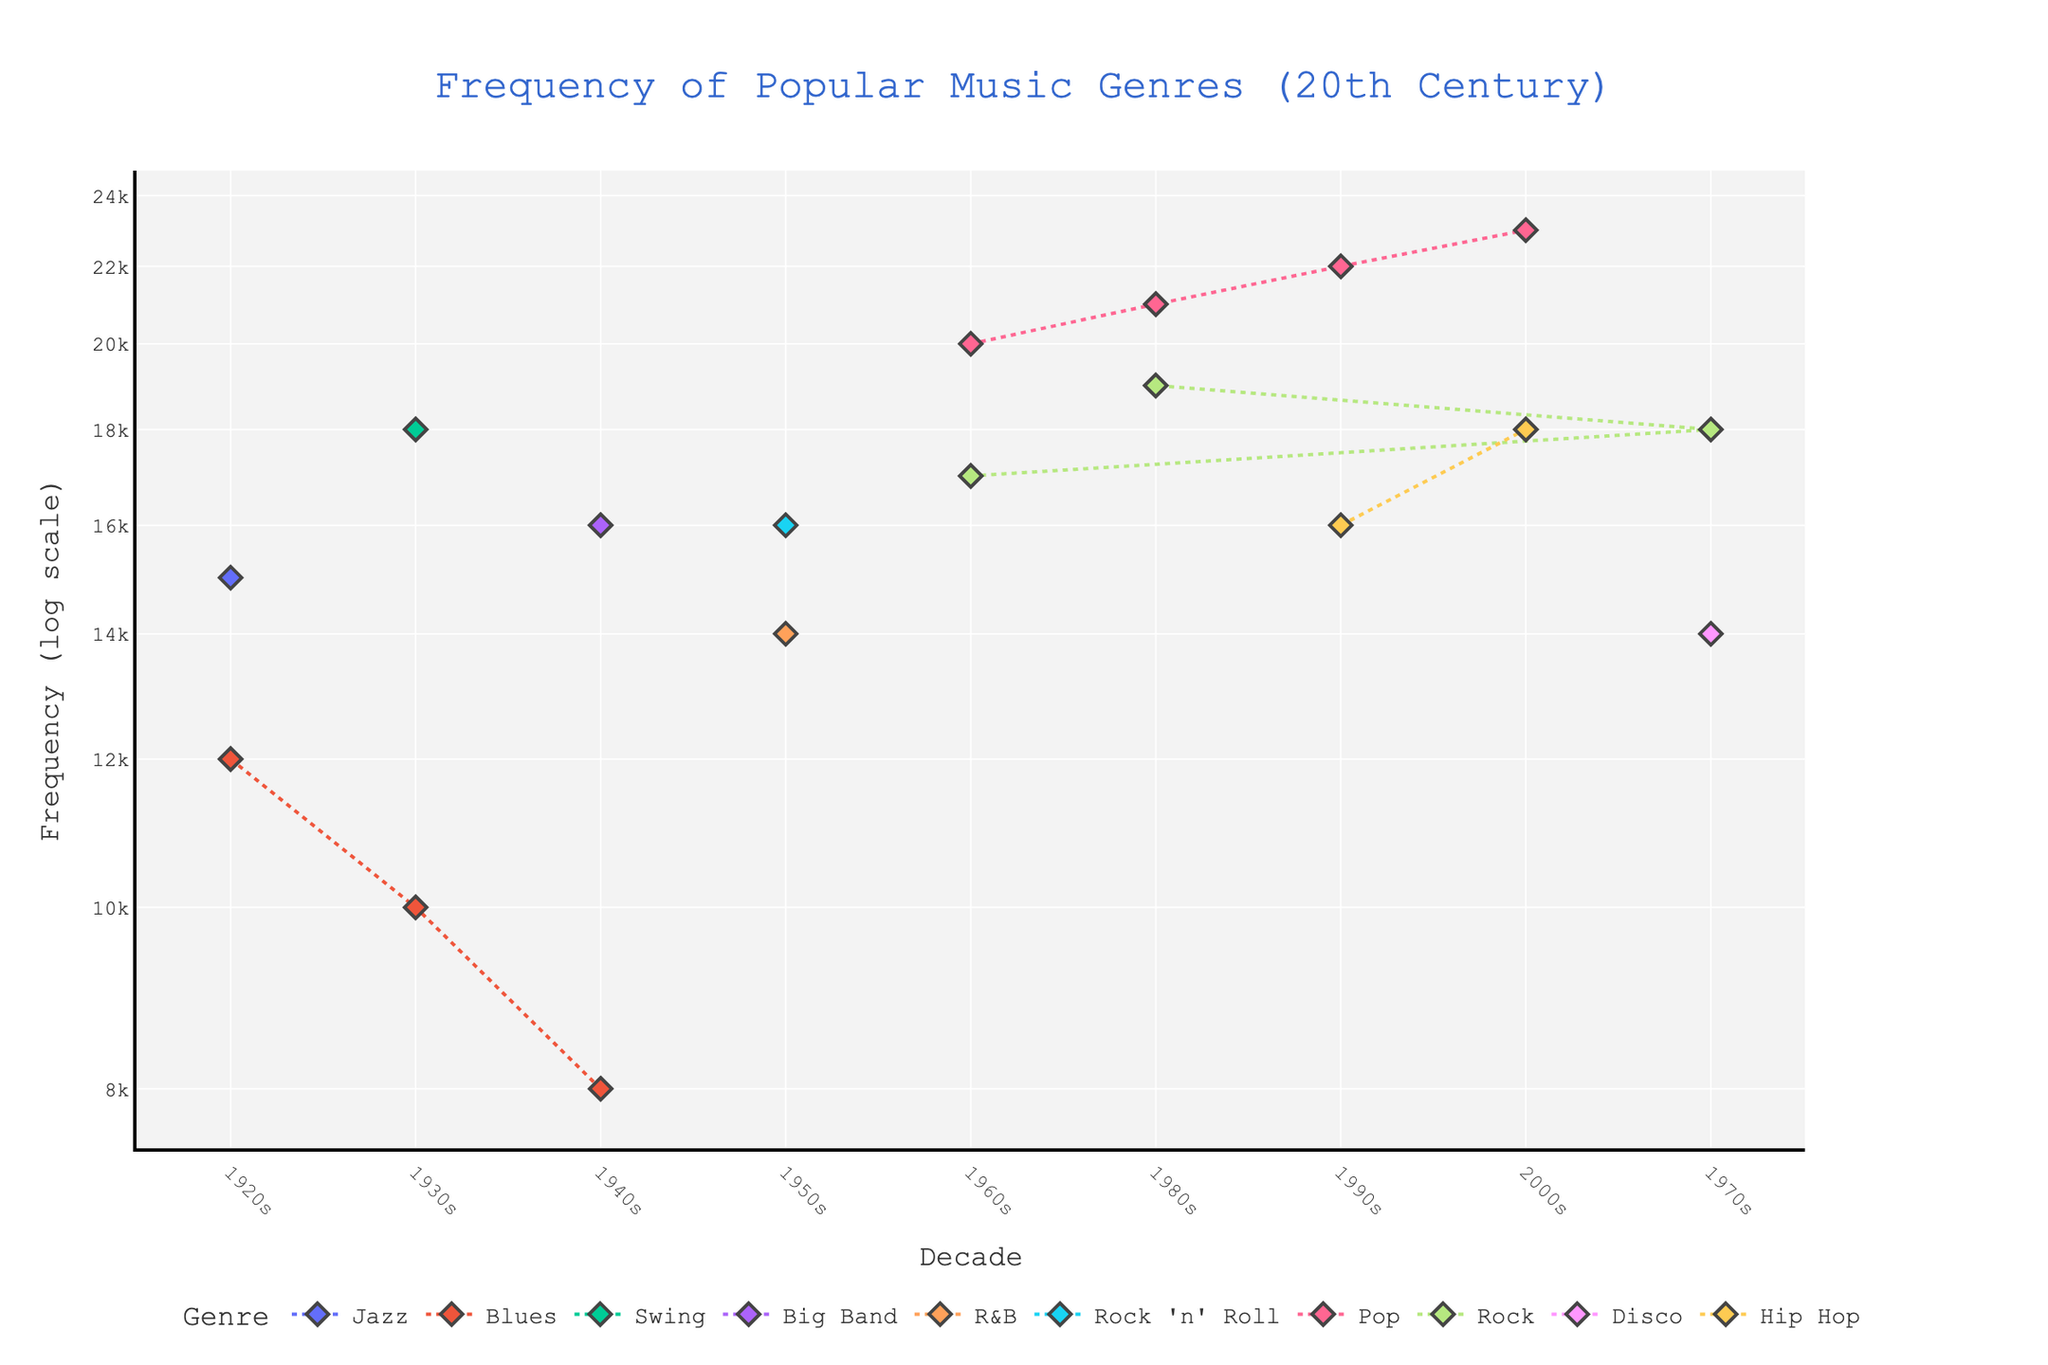What is the title of the plot? Look at the top of the plot where the title is located.
Answer: Frequency of Popular Music Genres (20th Century) How many genres are represented in the plot? Count the unique genres listed in the legend or within the plot data points.
Answer: 10 Which genre had the highest frequency in the 1980s? Identify the data points corresponding to the 1980s and compare their frequencies.
Answer: Pop Which decade had the highest frequency for Pop music? Look at the data points for Pop music across all decades and identify the highest frequency.
Answer: 2000s How does the frequency of Rock music in the 1960s compare to the 1970s? Find the frequencies of Rock music in the 1960s (17000) and 1970s (18000) and compare them.
Answer: 1970s has a higher frequency by 1000 Which genres were popular in both the 1920s and 1930s? Identify the genres listed in both the 1920s and 1930s and compare them.
Answer: Blues Does the frequency of Blues music increase or decrease from the 1920s to the 1940s? Compare the frequency values of Blues music across the 1920s (12000), 1930s (10000), and 1940s (8000).
Answer: Decrease Which genre shows a continuous increase in frequency from the 1950s to the 2000s? Examine the genres' frequencies across these decades and look for an increasing trend.
Answer: Pop What is the average frequency of Disco music in the 1970s? There is only one data point for Disco in the 1970s with a frequency of 14000.
Answer: 14000 